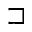Convert formula to latex. <formula><loc_0><loc_0><loc_500><loc_500>\sqsupset</formula> 